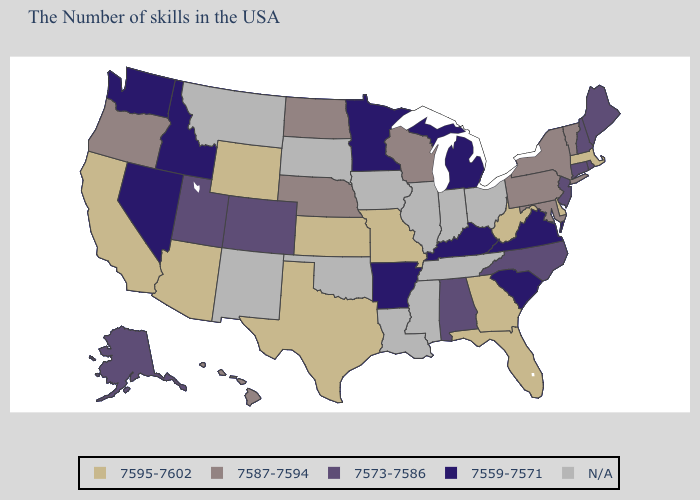What is the value of Florida?
Short answer required. 7595-7602. Name the states that have a value in the range 7595-7602?
Short answer required. Massachusetts, Delaware, West Virginia, Florida, Georgia, Missouri, Kansas, Texas, Wyoming, Arizona, California. What is the value of South Carolina?
Short answer required. 7559-7571. Among the states that border Georgia , does South Carolina have the lowest value?
Short answer required. Yes. What is the value of Missouri?
Answer briefly. 7595-7602. What is the highest value in the USA?
Give a very brief answer. 7595-7602. Does Massachusetts have the highest value in the USA?
Answer briefly. Yes. What is the value of Florida?
Concise answer only. 7595-7602. Name the states that have a value in the range 7573-7586?
Give a very brief answer. Maine, Rhode Island, New Hampshire, Connecticut, New Jersey, North Carolina, Alabama, Colorado, Utah, Alaska. Name the states that have a value in the range 7559-7571?
Be succinct. Virginia, South Carolina, Michigan, Kentucky, Arkansas, Minnesota, Idaho, Nevada, Washington. What is the value of North Dakota?
Short answer required. 7587-7594. Among the states that border Montana , does Idaho have the lowest value?
Quick response, please. Yes. What is the lowest value in the MidWest?
Write a very short answer. 7559-7571. Is the legend a continuous bar?
Write a very short answer. No. Among the states that border Kansas , does Missouri have the highest value?
Give a very brief answer. Yes. 